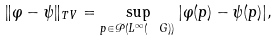Convert formula to latex. <formula><loc_0><loc_0><loc_500><loc_500>\| \varphi - \psi \| _ { T V } = \sup _ { p \in \mathcal { P } ( L ^ { \infty } ( \ G ) ) } | \varphi ( p ) - \psi ( p ) | ,</formula> 